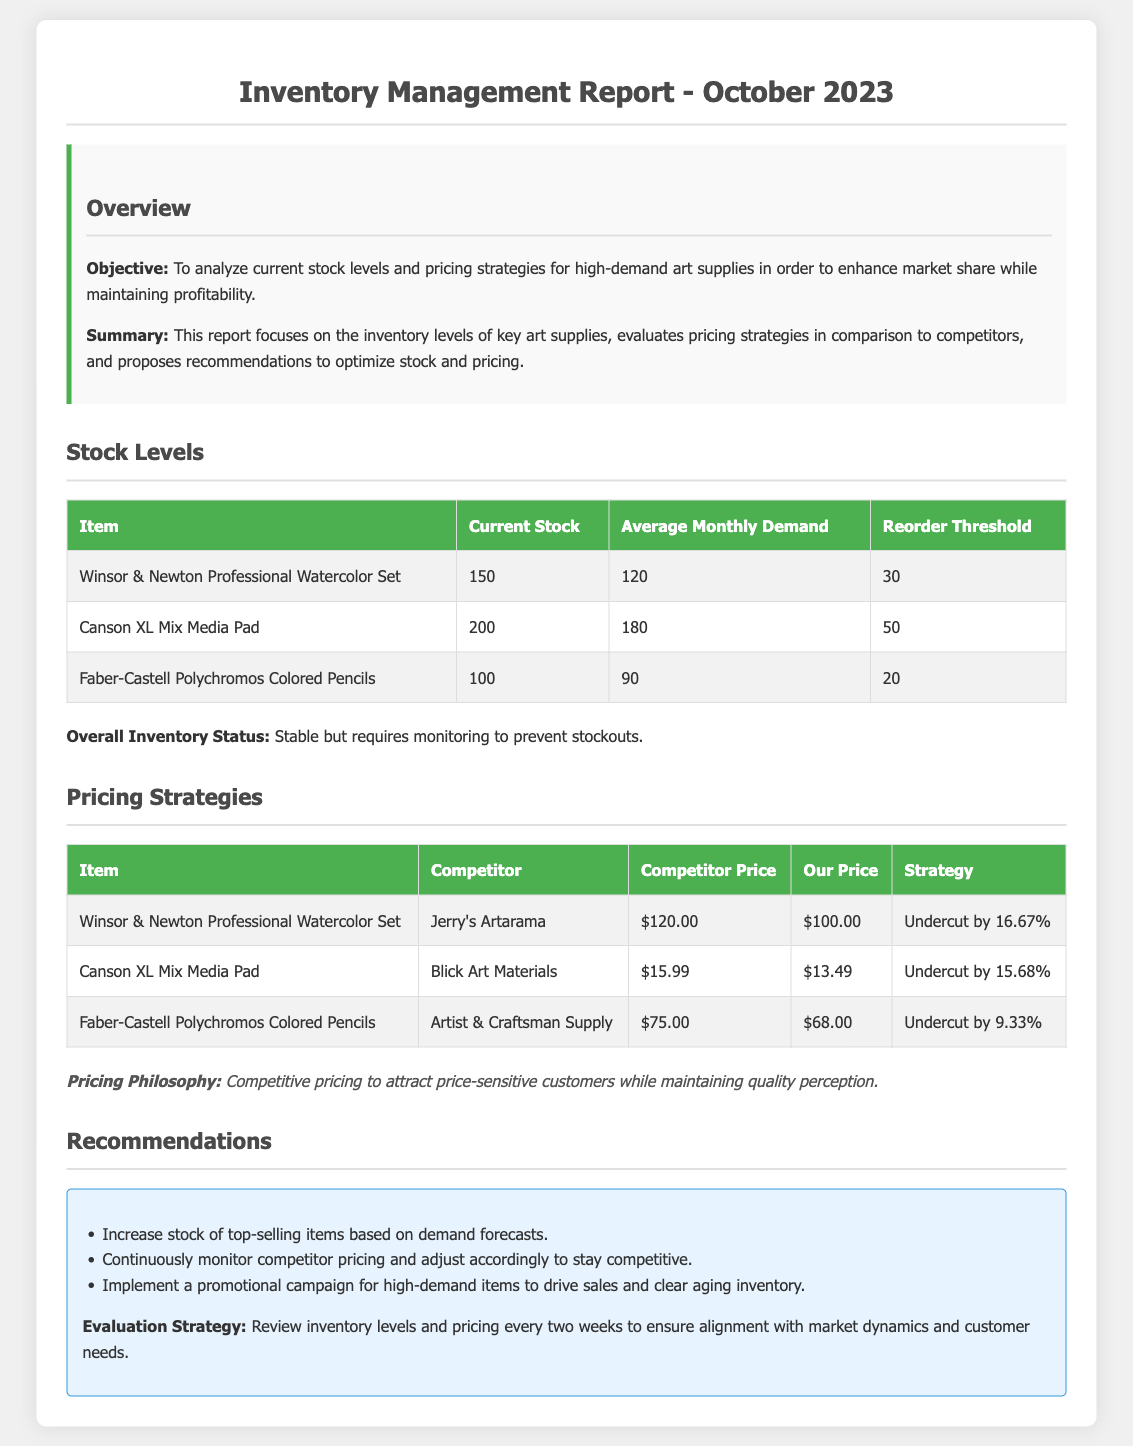what is the current stock of Winsor & Newton Professional Watercolor Set? The current stock of Winsor & Newton Professional Watercolor Set is listed in the 'Stock Levels' table.
Answer: 150 what is the reorder threshold for Canson XL Mix Media Pad? The reorder threshold is a specific level indicated in the 'Stock Levels' table for each item.
Answer: 50 who is the competitor for Faber-Castell Polychromos Colored Pencils? The competitor is clearly stated in the 'Pricing Strategies' table next to the respective item.
Answer: Artist & Craftsman Supply what is our price for Canson XL Mix Media Pad? The price is provided in the 'Pricing Strategies' table next to the item listing.
Answer: $13.49 how much do we undercut the price of Winsor & Newton Professional Watercolor Set? The price difference between our price and competitor’s price shows the undercut percentage in the 'Pricing Strategies' table.
Answer: Undercut by 16.67% what is the average monthly demand for Faber-Castell Polychromos Colored Pencils? The average monthly demand is indicated in the 'Stock Levels' table for Faber-Castell Polychromos Colored Pencils.
Answer: 90 what is the focus of this report? The focus is elaborated in the 'Overview' section describing what the report aims to achieve.
Answer: Analyze current stock levels and pricing strategies what recommendation is given for high-demand items? Recommendations are listed in the 'Recommendations' section where strategies for inventory management are stated.
Answer: Increase stock of top-selling items based on demand forecasts what is the evaluation strategy mentioned in the report? The evaluation strategy is mentioned in the 'Recommendations' section regarding the frequency of review.
Answer: Review inventory levels and pricing every two weeks 